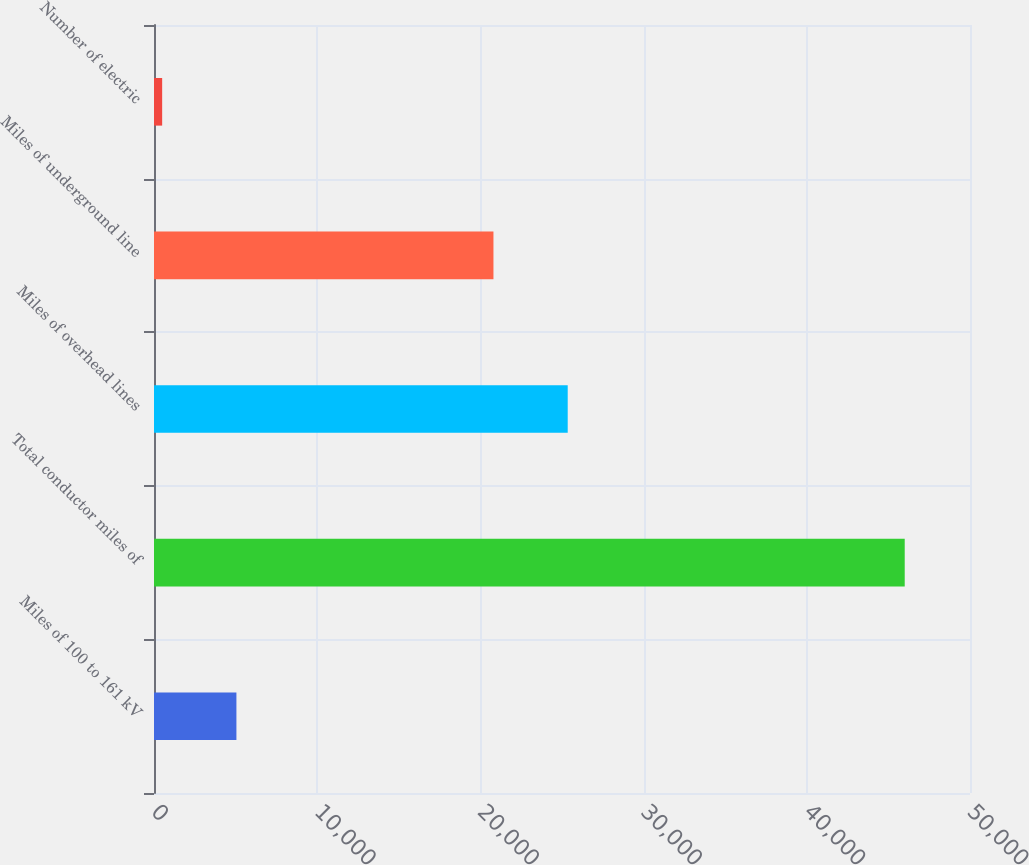Convert chart. <chart><loc_0><loc_0><loc_500><loc_500><bar_chart><fcel>Miles of 100 to 161 kV<fcel>Total conductor miles of<fcel>Miles of overhead lines<fcel>Miles of underground line<fcel>Number of electric<nl><fcel>5050<fcel>46000<fcel>25350<fcel>20800<fcel>500<nl></chart> 